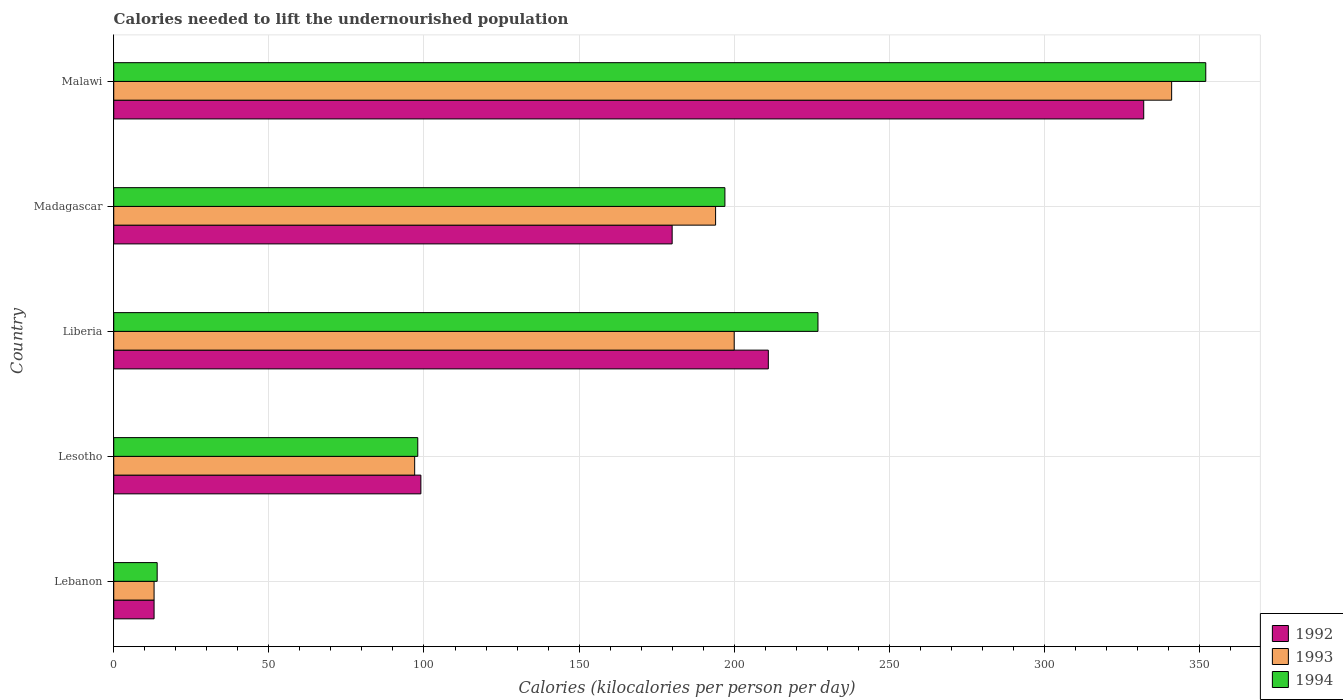How many different coloured bars are there?
Offer a terse response. 3. How many groups of bars are there?
Ensure brevity in your answer.  5. Are the number of bars per tick equal to the number of legend labels?
Ensure brevity in your answer.  Yes. How many bars are there on the 1st tick from the top?
Your answer should be compact. 3. How many bars are there on the 2nd tick from the bottom?
Offer a very short reply. 3. What is the label of the 4th group of bars from the top?
Your answer should be compact. Lesotho. In how many cases, is the number of bars for a given country not equal to the number of legend labels?
Your response must be concise. 0. What is the total calories needed to lift the undernourished population in 1993 in Lebanon?
Your response must be concise. 13. Across all countries, what is the maximum total calories needed to lift the undernourished population in 1993?
Your response must be concise. 341. Across all countries, what is the minimum total calories needed to lift the undernourished population in 1993?
Provide a short and direct response. 13. In which country was the total calories needed to lift the undernourished population in 1994 maximum?
Make the answer very short. Malawi. In which country was the total calories needed to lift the undernourished population in 1992 minimum?
Give a very brief answer. Lebanon. What is the total total calories needed to lift the undernourished population in 1994 in the graph?
Give a very brief answer. 888. What is the difference between the total calories needed to lift the undernourished population in 1993 in Lesotho and that in Liberia?
Give a very brief answer. -103. What is the difference between the total calories needed to lift the undernourished population in 1992 in Lebanon and the total calories needed to lift the undernourished population in 1994 in Madagascar?
Ensure brevity in your answer.  -184. What is the average total calories needed to lift the undernourished population in 1992 per country?
Your response must be concise. 167. In how many countries, is the total calories needed to lift the undernourished population in 1992 greater than 120 kilocalories?
Provide a short and direct response. 3. What is the ratio of the total calories needed to lift the undernourished population in 1993 in Lesotho to that in Liberia?
Provide a short and direct response. 0.48. Is the difference between the total calories needed to lift the undernourished population in 1994 in Lebanon and Lesotho greater than the difference between the total calories needed to lift the undernourished population in 1992 in Lebanon and Lesotho?
Provide a short and direct response. Yes. What is the difference between the highest and the second highest total calories needed to lift the undernourished population in 1992?
Your answer should be compact. 121. What is the difference between the highest and the lowest total calories needed to lift the undernourished population in 1992?
Offer a very short reply. 319. In how many countries, is the total calories needed to lift the undernourished population in 1994 greater than the average total calories needed to lift the undernourished population in 1994 taken over all countries?
Provide a short and direct response. 3. What does the 3rd bar from the top in Lebanon represents?
Make the answer very short. 1992. What does the 2nd bar from the bottom in Lebanon represents?
Make the answer very short. 1993. Is it the case that in every country, the sum of the total calories needed to lift the undernourished population in 1994 and total calories needed to lift the undernourished population in 1993 is greater than the total calories needed to lift the undernourished population in 1992?
Offer a terse response. Yes. Are all the bars in the graph horizontal?
Your response must be concise. Yes. How many countries are there in the graph?
Offer a very short reply. 5. What is the difference between two consecutive major ticks on the X-axis?
Offer a terse response. 50. Does the graph contain any zero values?
Keep it short and to the point. No. How many legend labels are there?
Provide a succinct answer. 3. How are the legend labels stacked?
Your response must be concise. Vertical. What is the title of the graph?
Make the answer very short. Calories needed to lift the undernourished population. What is the label or title of the X-axis?
Give a very brief answer. Calories (kilocalories per person per day). What is the Calories (kilocalories per person per day) of 1994 in Lebanon?
Your answer should be very brief. 14. What is the Calories (kilocalories per person per day) of 1992 in Lesotho?
Make the answer very short. 99. What is the Calories (kilocalories per person per day) in 1993 in Lesotho?
Make the answer very short. 97. What is the Calories (kilocalories per person per day) in 1994 in Lesotho?
Your answer should be very brief. 98. What is the Calories (kilocalories per person per day) in 1992 in Liberia?
Your response must be concise. 211. What is the Calories (kilocalories per person per day) of 1994 in Liberia?
Keep it short and to the point. 227. What is the Calories (kilocalories per person per day) in 1992 in Madagascar?
Provide a succinct answer. 180. What is the Calories (kilocalories per person per day) in 1993 in Madagascar?
Your answer should be very brief. 194. What is the Calories (kilocalories per person per day) in 1994 in Madagascar?
Give a very brief answer. 197. What is the Calories (kilocalories per person per day) in 1992 in Malawi?
Keep it short and to the point. 332. What is the Calories (kilocalories per person per day) of 1993 in Malawi?
Provide a succinct answer. 341. What is the Calories (kilocalories per person per day) of 1994 in Malawi?
Offer a terse response. 352. Across all countries, what is the maximum Calories (kilocalories per person per day) of 1992?
Your answer should be compact. 332. Across all countries, what is the maximum Calories (kilocalories per person per day) of 1993?
Your answer should be compact. 341. Across all countries, what is the maximum Calories (kilocalories per person per day) in 1994?
Keep it short and to the point. 352. What is the total Calories (kilocalories per person per day) of 1992 in the graph?
Provide a short and direct response. 835. What is the total Calories (kilocalories per person per day) in 1993 in the graph?
Offer a terse response. 845. What is the total Calories (kilocalories per person per day) of 1994 in the graph?
Offer a terse response. 888. What is the difference between the Calories (kilocalories per person per day) of 1992 in Lebanon and that in Lesotho?
Offer a very short reply. -86. What is the difference between the Calories (kilocalories per person per day) in 1993 in Lebanon and that in Lesotho?
Provide a succinct answer. -84. What is the difference between the Calories (kilocalories per person per day) of 1994 in Lebanon and that in Lesotho?
Keep it short and to the point. -84. What is the difference between the Calories (kilocalories per person per day) in 1992 in Lebanon and that in Liberia?
Ensure brevity in your answer.  -198. What is the difference between the Calories (kilocalories per person per day) in 1993 in Lebanon and that in Liberia?
Offer a very short reply. -187. What is the difference between the Calories (kilocalories per person per day) in 1994 in Lebanon and that in Liberia?
Offer a terse response. -213. What is the difference between the Calories (kilocalories per person per day) in 1992 in Lebanon and that in Madagascar?
Provide a succinct answer. -167. What is the difference between the Calories (kilocalories per person per day) of 1993 in Lebanon and that in Madagascar?
Your answer should be compact. -181. What is the difference between the Calories (kilocalories per person per day) in 1994 in Lebanon and that in Madagascar?
Provide a succinct answer. -183. What is the difference between the Calories (kilocalories per person per day) of 1992 in Lebanon and that in Malawi?
Keep it short and to the point. -319. What is the difference between the Calories (kilocalories per person per day) of 1993 in Lebanon and that in Malawi?
Provide a succinct answer. -328. What is the difference between the Calories (kilocalories per person per day) in 1994 in Lebanon and that in Malawi?
Keep it short and to the point. -338. What is the difference between the Calories (kilocalories per person per day) in 1992 in Lesotho and that in Liberia?
Offer a terse response. -112. What is the difference between the Calories (kilocalories per person per day) in 1993 in Lesotho and that in Liberia?
Give a very brief answer. -103. What is the difference between the Calories (kilocalories per person per day) in 1994 in Lesotho and that in Liberia?
Offer a very short reply. -129. What is the difference between the Calories (kilocalories per person per day) in 1992 in Lesotho and that in Madagascar?
Your answer should be compact. -81. What is the difference between the Calories (kilocalories per person per day) in 1993 in Lesotho and that in Madagascar?
Offer a terse response. -97. What is the difference between the Calories (kilocalories per person per day) in 1994 in Lesotho and that in Madagascar?
Offer a terse response. -99. What is the difference between the Calories (kilocalories per person per day) in 1992 in Lesotho and that in Malawi?
Keep it short and to the point. -233. What is the difference between the Calories (kilocalories per person per day) in 1993 in Lesotho and that in Malawi?
Your response must be concise. -244. What is the difference between the Calories (kilocalories per person per day) in 1994 in Lesotho and that in Malawi?
Your response must be concise. -254. What is the difference between the Calories (kilocalories per person per day) in 1994 in Liberia and that in Madagascar?
Provide a short and direct response. 30. What is the difference between the Calories (kilocalories per person per day) of 1992 in Liberia and that in Malawi?
Your response must be concise. -121. What is the difference between the Calories (kilocalories per person per day) of 1993 in Liberia and that in Malawi?
Keep it short and to the point. -141. What is the difference between the Calories (kilocalories per person per day) of 1994 in Liberia and that in Malawi?
Provide a succinct answer. -125. What is the difference between the Calories (kilocalories per person per day) in 1992 in Madagascar and that in Malawi?
Offer a terse response. -152. What is the difference between the Calories (kilocalories per person per day) of 1993 in Madagascar and that in Malawi?
Offer a terse response. -147. What is the difference between the Calories (kilocalories per person per day) in 1994 in Madagascar and that in Malawi?
Make the answer very short. -155. What is the difference between the Calories (kilocalories per person per day) of 1992 in Lebanon and the Calories (kilocalories per person per day) of 1993 in Lesotho?
Your response must be concise. -84. What is the difference between the Calories (kilocalories per person per day) of 1992 in Lebanon and the Calories (kilocalories per person per day) of 1994 in Lesotho?
Your answer should be compact. -85. What is the difference between the Calories (kilocalories per person per day) of 1993 in Lebanon and the Calories (kilocalories per person per day) of 1994 in Lesotho?
Ensure brevity in your answer.  -85. What is the difference between the Calories (kilocalories per person per day) of 1992 in Lebanon and the Calories (kilocalories per person per day) of 1993 in Liberia?
Ensure brevity in your answer.  -187. What is the difference between the Calories (kilocalories per person per day) of 1992 in Lebanon and the Calories (kilocalories per person per day) of 1994 in Liberia?
Keep it short and to the point. -214. What is the difference between the Calories (kilocalories per person per day) in 1993 in Lebanon and the Calories (kilocalories per person per day) in 1994 in Liberia?
Offer a terse response. -214. What is the difference between the Calories (kilocalories per person per day) of 1992 in Lebanon and the Calories (kilocalories per person per day) of 1993 in Madagascar?
Your response must be concise. -181. What is the difference between the Calories (kilocalories per person per day) in 1992 in Lebanon and the Calories (kilocalories per person per day) in 1994 in Madagascar?
Give a very brief answer. -184. What is the difference between the Calories (kilocalories per person per day) in 1993 in Lebanon and the Calories (kilocalories per person per day) in 1994 in Madagascar?
Make the answer very short. -184. What is the difference between the Calories (kilocalories per person per day) of 1992 in Lebanon and the Calories (kilocalories per person per day) of 1993 in Malawi?
Provide a succinct answer. -328. What is the difference between the Calories (kilocalories per person per day) in 1992 in Lebanon and the Calories (kilocalories per person per day) in 1994 in Malawi?
Provide a short and direct response. -339. What is the difference between the Calories (kilocalories per person per day) of 1993 in Lebanon and the Calories (kilocalories per person per day) of 1994 in Malawi?
Offer a terse response. -339. What is the difference between the Calories (kilocalories per person per day) of 1992 in Lesotho and the Calories (kilocalories per person per day) of 1993 in Liberia?
Provide a short and direct response. -101. What is the difference between the Calories (kilocalories per person per day) of 1992 in Lesotho and the Calories (kilocalories per person per day) of 1994 in Liberia?
Your answer should be very brief. -128. What is the difference between the Calories (kilocalories per person per day) of 1993 in Lesotho and the Calories (kilocalories per person per day) of 1994 in Liberia?
Provide a short and direct response. -130. What is the difference between the Calories (kilocalories per person per day) in 1992 in Lesotho and the Calories (kilocalories per person per day) in 1993 in Madagascar?
Ensure brevity in your answer.  -95. What is the difference between the Calories (kilocalories per person per day) in 1992 in Lesotho and the Calories (kilocalories per person per day) in 1994 in Madagascar?
Provide a succinct answer. -98. What is the difference between the Calories (kilocalories per person per day) in 1993 in Lesotho and the Calories (kilocalories per person per day) in 1994 in Madagascar?
Your answer should be compact. -100. What is the difference between the Calories (kilocalories per person per day) in 1992 in Lesotho and the Calories (kilocalories per person per day) in 1993 in Malawi?
Ensure brevity in your answer.  -242. What is the difference between the Calories (kilocalories per person per day) of 1992 in Lesotho and the Calories (kilocalories per person per day) of 1994 in Malawi?
Your answer should be compact. -253. What is the difference between the Calories (kilocalories per person per day) in 1993 in Lesotho and the Calories (kilocalories per person per day) in 1994 in Malawi?
Give a very brief answer. -255. What is the difference between the Calories (kilocalories per person per day) in 1992 in Liberia and the Calories (kilocalories per person per day) in 1994 in Madagascar?
Provide a succinct answer. 14. What is the difference between the Calories (kilocalories per person per day) in 1992 in Liberia and the Calories (kilocalories per person per day) in 1993 in Malawi?
Your response must be concise. -130. What is the difference between the Calories (kilocalories per person per day) of 1992 in Liberia and the Calories (kilocalories per person per day) of 1994 in Malawi?
Your response must be concise. -141. What is the difference between the Calories (kilocalories per person per day) of 1993 in Liberia and the Calories (kilocalories per person per day) of 1994 in Malawi?
Your response must be concise. -152. What is the difference between the Calories (kilocalories per person per day) of 1992 in Madagascar and the Calories (kilocalories per person per day) of 1993 in Malawi?
Provide a succinct answer. -161. What is the difference between the Calories (kilocalories per person per day) of 1992 in Madagascar and the Calories (kilocalories per person per day) of 1994 in Malawi?
Your response must be concise. -172. What is the difference between the Calories (kilocalories per person per day) of 1993 in Madagascar and the Calories (kilocalories per person per day) of 1994 in Malawi?
Make the answer very short. -158. What is the average Calories (kilocalories per person per day) of 1992 per country?
Offer a terse response. 167. What is the average Calories (kilocalories per person per day) of 1993 per country?
Give a very brief answer. 169. What is the average Calories (kilocalories per person per day) in 1994 per country?
Offer a terse response. 177.6. What is the difference between the Calories (kilocalories per person per day) in 1993 and Calories (kilocalories per person per day) in 1994 in Lebanon?
Keep it short and to the point. -1. What is the difference between the Calories (kilocalories per person per day) of 1992 and Calories (kilocalories per person per day) of 1993 in Liberia?
Provide a succinct answer. 11. What is the difference between the Calories (kilocalories per person per day) of 1992 and Calories (kilocalories per person per day) of 1994 in Madagascar?
Offer a terse response. -17. What is the difference between the Calories (kilocalories per person per day) of 1993 and Calories (kilocalories per person per day) of 1994 in Malawi?
Make the answer very short. -11. What is the ratio of the Calories (kilocalories per person per day) in 1992 in Lebanon to that in Lesotho?
Offer a very short reply. 0.13. What is the ratio of the Calories (kilocalories per person per day) in 1993 in Lebanon to that in Lesotho?
Your answer should be compact. 0.13. What is the ratio of the Calories (kilocalories per person per day) in 1994 in Lebanon to that in Lesotho?
Ensure brevity in your answer.  0.14. What is the ratio of the Calories (kilocalories per person per day) of 1992 in Lebanon to that in Liberia?
Ensure brevity in your answer.  0.06. What is the ratio of the Calories (kilocalories per person per day) in 1993 in Lebanon to that in Liberia?
Give a very brief answer. 0.07. What is the ratio of the Calories (kilocalories per person per day) of 1994 in Lebanon to that in Liberia?
Give a very brief answer. 0.06. What is the ratio of the Calories (kilocalories per person per day) in 1992 in Lebanon to that in Madagascar?
Your answer should be compact. 0.07. What is the ratio of the Calories (kilocalories per person per day) of 1993 in Lebanon to that in Madagascar?
Provide a succinct answer. 0.07. What is the ratio of the Calories (kilocalories per person per day) in 1994 in Lebanon to that in Madagascar?
Keep it short and to the point. 0.07. What is the ratio of the Calories (kilocalories per person per day) in 1992 in Lebanon to that in Malawi?
Your answer should be very brief. 0.04. What is the ratio of the Calories (kilocalories per person per day) in 1993 in Lebanon to that in Malawi?
Make the answer very short. 0.04. What is the ratio of the Calories (kilocalories per person per day) of 1994 in Lebanon to that in Malawi?
Offer a very short reply. 0.04. What is the ratio of the Calories (kilocalories per person per day) in 1992 in Lesotho to that in Liberia?
Offer a terse response. 0.47. What is the ratio of the Calories (kilocalories per person per day) of 1993 in Lesotho to that in Liberia?
Offer a terse response. 0.48. What is the ratio of the Calories (kilocalories per person per day) of 1994 in Lesotho to that in Liberia?
Make the answer very short. 0.43. What is the ratio of the Calories (kilocalories per person per day) in 1992 in Lesotho to that in Madagascar?
Keep it short and to the point. 0.55. What is the ratio of the Calories (kilocalories per person per day) of 1993 in Lesotho to that in Madagascar?
Your answer should be compact. 0.5. What is the ratio of the Calories (kilocalories per person per day) of 1994 in Lesotho to that in Madagascar?
Provide a short and direct response. 0.5. What is the ratio of the Calories (kilocalories per person per day) in 1992 in Lesotho to that in Malawi?
Your answer should be very brief. 0.3. What is the ratio of the Calories (kilocalories per person per day) of 1993 in Lesotho to that in Malawi?
Provide a short and direct response. 0.28. What is the ratio of the Calories (kilocalories per person per day) of 1994 in Lesotho to that in Malawi?
Ensure brevity in your answer.  0.28. What is the ratio of the Calories (kilocalories per person per day) of 1992 in Liberia to that in Madagascar?
Provide a short and direct response. 1.17. What is the ratio of the Calories (kilocalories per person per day) in 1993 in Liberia to that in Madagascar?
Keep it short and to the point. 1.03. What is the ratio of the Calories (kilocalories per person per day) in 1994 in Liberia to that in Madagascar?
Provide a short and direct response. 1.15. What is the ratio of the Calories (kilocalories per person per day) in 1992 in Liberia to that in Malawi?
Provide a short and direct response. 0.64. What is the ratio of the Calories (kilocalories per person per day) in 1993 in Liberia to that in Malawi?
Your answer should be compact. 0.59. What is the ratio of the Calories (kilocalories per person per day) in 1994 in Liberia to that in Malawi?
Offer a very short reply. 0.64. What is the ratio of the Calories (kilocalories per person per day) in 1992 in Madagascar to that in Malawi?
Provide a short and direct response. 0.54. What is the ratio of the Calories (kilocalories per person per day) of 1993 in Madagascar to that in Malawi?
Provide a succinct answer. 0.57. What is the ratio of the Calories (kilocalories per person per day) of 1994 in Madagascar to that in Malawi?
Your response must be concise. 0.56. What is the difference between the highest and the second highest Calories (kilocalories per person per day) in 1992?
Offer a very short reply. 121. What is the difference between the highest and the second highest Calories (kilocalories per person per day) in 1993?
Your answer should be very brief. 141. What is the difference between the highest and the second highest Calories (kilocalories per person per day) in 1994?
Your answer should be compact. 125. What is the difference between the highest and the lowest Calories (kilocalories per person per day) of 1992?
Your answer should be very brief. 319. What is the difference between the highest and the lowest Calories (kilocalories per person per day) in 1993?
Offer a very short reply. 328. What is the difference between the highest and the lowest Calories (kilocalories per person per day) in 1994?
Give a very brief answer. 338. 